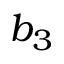<formula> <loc_0><loc_0><loc_500><loc_500>b _ { 3 }</formula> 